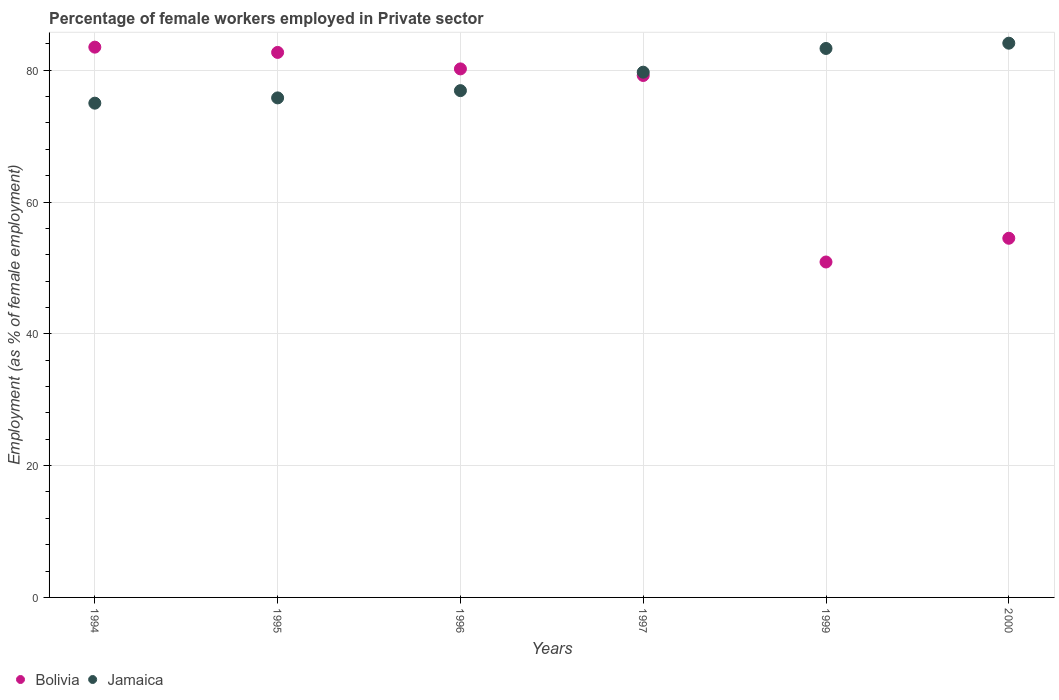How many different coloured dotlines are there?
Your answer should be very brief. 2. What is the percentage of females employed in Private sector in Jamaica in 1997?
Provide a succinct answer. 79.7. Across all years, what is the maximum percentage of females employed in Private sector in Jamaica?
Make the answer very short. 84.1. Across all years, what is the minimum percentage of females employed in Private sector in Jamaica?
Your answer should be very brief. 75. In which year was the percentage of females employed in Private sector in Bolivia maximum?
Give a very brief answer. 1994. What is the total percentage of females employed in Private sector in Bolivia in the graph?
Offer a very short reply. 431. What is the difference between the percentage of females employed in Private sector in Bolivia in 1995 and that in 1996?
Ensure brevity in your answer.  2.5. What is the difference between the percentage of females employed in Private sector in Jamaica in 1999 and the percentage of females employed in Private sector in Bolivia in 1996?
Provide a succinct answer. 3.1. What is the average percentage of females employed in Private sector in Jamaica per year?
Ensure brevity in your answer.  79.13. What is the ratio of the percentage of females employed in Private sector in Bolivia in 1995 to that in 1996?
Provide a succinct answer. 1.03. Is the percentage of females employed in Private sector in Bolivia in 1996 less than that in 2000?
Ensure brevity in your answer.  No. What is the difference between the highest and the second highest percentage of females employed in Private sector in Jamaica?
Your answer should be very brief. 0.8. What is the difference between the highest and the lowest percentage of females employed in Private sector in Jamaica?
Make the answer very short. 9.1. In how many years, is the percentage of females employed in Private sector in Bolivia greater than the average percentage of females employed in Private sector in Bolivia taken over all years?
Offer a very short reply. 4. Is the sum of the percentage of females employed in Private sector in Jamaica in 1994 and 1999 greater than the maximum percentage of females employed in Private sector in Bolivia across all years?
Provide a succinct answer. Yes. Does the percentage of females employed in Private sector in Jamaica monotonically increase over the years?
Keep it short and to the point. Yes. Is the percentage of females employed in Private sector in Bolivia strictly greater than the percentage of females employed in Private sector in Jamaica over the years?
Provide a succinct answer. No. What is the difference between two consecutive major ticks on the Y-axis?
Ensure brevity in your answer.  20. Are the values on the major ticks of Y-axis written in scientific E-notation?
Your response must be concise. No. Where does the legend appear in the graph?
Your answer should be compact. Bottom left. How many legend labels are there?
Your answer should be very brief. 2. How are the legend labels stacked?
Keep it short and to the point. Horizontal. What is the title of the graph?
Make the answer very short. Percentage of female workers employed in Private sector. What is the label or title of the Y-axis?
Your answer should be compact. Employment (as % of female employment). What is the Employment (as % of female employment) of Bolivia in 1994?
Ensure brevity in your answer.  83.5. What is the Employment (as % of female employment) in Jamaica in 1994?
Keep it short and to the point. 75. What is the Employment (as % of female employment) of Bolivia in 1995?
Give a very brief answer. 82.7. What is the Employment (as % of female employment) in Jamaica in 1995?
Offer a terse response. 75.8. What is the Employment (as % of female employment) of Bolivia in 1996?
Give a very brief answer. 80.2. What is the Employment (as % of female employment) in Jamaica in 1996?
Offer a terse response. 76.9. What is the Employment (as % of female employment) of Bolivia in 1997?
Your answer should be compact. 79.2. What is the Employment (as % of female employment) of Jamaica in 1997?
Give a very brief answer. 79.7. What is the Employment (as % of female employment) in Bolivia in 1999?
Your response must be concise. 50.9. What is the Employment (as % of female employment) in Jamaica in 1999?
Your response must be concise. 83.3. What is the Employment (as % of female employment) of Bolivia in 2000?
Make the answer very short. 54.5. What is the Employment (as % of female employment) in Jamaica in 2000?
Your answer should be very brief. 84.1. Across all years, what is the maximum Employment (as % of female employment) in Bolivia?
Your answer should be very brief. 83.5. Across all years, what is the maximum Employment (as % of female employment) in Jamaica?
Your answer should be very brief. 84.1. Across all years, what is the minimum Employment (as % of female employment) of Bolivia?
Your answer should be very brief. 50.9. What is the total Employment (as % of female employment) in Bolivia in the graph?
Offer a very short reply. 431. What is the total Employment (as % of female employment) in Jamaica in the graph?
Provide a succinct answer. 474.8. What is the difference between the Employment (as % of female employment) of Jamaica in 1994 and that in 1995?
Your answer should be very brief. -0.8. What is the difference between the Employment (as % of female employment) of Bolivia in 1994 and that in 1996?
Provide a succinct answer. 3.3. What is the difference between the Employment (as % of female employment) in Bolivia in 1994 and that in 1997?
Offer a terse response. 4.3. What is the difference between the Employment (as % of female employment) in Jamaica in 1994 and that in 1997?
Make the answer very short. -4.7. What is the difference between the Employment (as % of female employment) of Bolivia in 1994 and that in 1999?
Provide a succinct answer. 32.6. What is the difference between the Employment (as % of female employment) of Bolivia in 1995 and that in 1997?
Your answer should be very brief. 3.5. What is the difference between the Employment (as % of female employment) in Jamaica in 1995 and that in 1997?
Your response must be concise. -3.9. What is the difference between the Employment (as % of female employment) in Bolivia in 1995 and that in 1999?
Make the answer very short. 31.8. What is the difference between the Employment (as % of female employment) of Bolivia in 1995 and that in 2000?
Offer a very short reply. 28.2. What is the difference between the Employment (as % of female employment) of Bolivia in 1996 and that in 1997?
Your response must be concise. 1. What is the difference between the Employment (as % of female employment) in Jamaica in 1996 and that in 1997?
Offer a terse response. -2.8. What is the difference between the Employment (as % of female employment) of Bolivia in 1996 and that in 1999?
Provide a succinct answer. 29.3. What is the difference between the Employment (as % of female employment) of Jamaica in 1996 and that in 1999?
Your answer should be compact. -6.4. What is the difference between the Employment (as % of female employment) in Bolivia in 1996 and that in 2000?
Ensure brevity in your answer.  25.7. What is the difference between the Employment (as % of female employment) of Bolivia in 1997 and that in 1999?
Your response must be concise. 28.3. What is the difference between the Employment (as % of female employment) of Jamaica in 1997 and that in 1999?
Make the answer very short. -3.6. What is the difference between the Employment (as % of female employment) of Bolivia in 1997 and that in 2000?
Provide a succinct answer. 24.7. What is the difference between the Employment (as % of female employment) of Bolivia in 1994 and the Employment (as % of female employment) of Jamaica in 1995?
Your answer should be compact. 7.7. What is the difference between the Employment (as % of female employment) in Bolivia in 1994 and the Employment (as % of female employment) in Jamaica in 1997?
Keep it short and to the point. 3.8. What is the difference between the Employment (as % of female employment) in Bolivia in 1994 and the Employment (as % of female employment) in Jamaica in 1999?
Your answer should be compact. 0.2. What is the difference between the Employment (as % of female employment) in Bolivia in 1995 and the Employment (as % of female employment) in Jamaica in 1997?
Keep it short and to the point. 3. What is the difference between the Employment (as % of female employment) in Bolivia in 1996 and the Employment (as % of female employment) in Jamaica in 1997?
Your answer should be very brief. 0.5. What is the difference between the Employment (as % of female employment) of Bolivia in 1999 and the Employment (as % of female employment) of Jamaica in 2000?
Make the answer very short. -33.2. What is the average Employment (as % of female employment) of Bolivia per year?
Offer a very short reply. 71.83. What is the average Employment (as % of female employment) of Jamaica per year?
Provide a succinct answer. 79.13. In the year 1999, what is the difference between the Employment (as % of female employment) in Bolivia and Employment (as % of female employment) in Jamaica?
Give a very brief answer. -32.4. In the year 2000, what is the difference between the Employment (as % of female employment) of Bolivia and Employment (as % of female employment) of Jamaica?
Give a very brief answer. -29.6. What is the ratio of the Employment (as % of female employment) of Bolivia in 1994 to that in 1995?
Provide a short and direct response. 1.01. What is the ratio of the Employment (as % of female employment) of Jamaica in 1994 to that in 1995?
Provide a succinct answer. 0.99. What is the ratio of the Employment (as % of female employment) in Bolivia in 1994 to that in 1996?
Ensure brevity in your answer.  1.04. What is the ratio of the Employment (as % of female employment) in Jamaica in 1994 to that in 1996?
Provide a succinct answer. 0.98. What is the ratio of the Employment (as % of female employment) in Bolivia in 1994 to that in 1997?
Your answer should be very brief. 1.05. What is the ratio of the Employment (as % of female employment) of Jamaica in 1994 to that in 1997?
Your response must be concise. 0.94. What is the ratio of the Employment (as % of female employment) in Bolivia in 1994 to that in 1999?
Provide a short and direct response. 1.64. What is the ratio of the Employment (as % of female employment) in Jamaica in 1994 to that in 1999?
Offer a terse response. 0.9. What is the ratio of the Employment (as % of female employment) in Bolivia in 1994 to that in 2000?
Provide a succinct answer. 1.53. What is the ratio of the Employment (as % of female employment) of Jamaica in 1994 to that in 2000?
Make the answer very short. 0.89. What is the ratio of the Employment (as % of female employment) of Bolivia in 1995 to that in 1996?
Offer a very short reply. 1.03. What is the ratio of the Employment (as % of female employment) in Jamaica in 1995 to that in 1996?
Provide a short and direct response. 0.99. What is the ratio of the Employment (as % of female employment) of Bolivia in 1995 to that in 1997?
Ensure brevity in your answer.  1.04. What is the ratio of the Employment (as % of female employment) in Jamaica in 1995 to that in 1997?
Ensure brevity in your answer.  0.95. What is the ratio of the Employment (as % of female employment) in Bolivia in 1995 to that in 1999?
Provide a short and direct response. 1.62. What is the ratio of the Employment (as % of female employment) in Jamaica in 1995 to that in 1999?
Your answer should be very brief. 0.91. What is the ratio of the Employment (as % of female employment) in Bolivia in 1995 to that in 2000?
Offer a very short reply. 1.52. What is the ratio of the Employment (as % of female employment) in Jamaica in 1995 to that in 2000?
Keep it short and to the point. 0.9. What is the ratio of the Employment (as % of female employment) in Bolivia in 1996 to that in 1997?
Provide a short and direct response. 1.01. What is the ratio of the Employment (as % of female employment) of Jamaica in 1996 to that in 1997?
Your answer should be compact. 0.96. What is the ratio of the Employment (as % of female employment) of Bolivia in 1996 to that in 1999?
Give a very brief answer. 1.58. What is the ratio of the Employment (as % of female employment) in Jamaica in 1996 to that in 1999?
Provide a succinct answer. 0.92. What is the ratio of the Employment (as % of female employment) in Bolivia in 1996 to that in 2000?
Provide a short and direct response. 1.47. What is the ratio of the Employment (as % of female employment) in Jamaica in 1996 to that in 2000?
Ensure brevity in your answer.  0.91. What is the ratio of the Employment (as % of female employment) in Bolivia in 1997 to that in 1999?
Your response must be concise. 1.56. What is the ratio of the Employment (as % of female employment) in Jamaica in 1997 to that in 1999?
Your response must be concise. 0.96. What is the ratio of the Employment (as % of female employment) in Bolivia in 1997 to that in 2000?
Keep it short and to the point. 1.45. What is the ratio of the Employment (as % of female employment) of Jamaica in 1997 to that in 2000?
Keep it short and to the point. 0.95. What is the ratio of the Employment (as % of female employment) in Bolivia in 1999 to that in 2000?
Offer a terse response. 0.93. What is the difference between the highest and the second highest Employment (as % of female employment) of Jamaica?
Give a very brief answer. 0.8. What is the difference between the highest and the lowest Employment (as % of female employment) of Bolivia?
Your response must be concise. 32.6. 